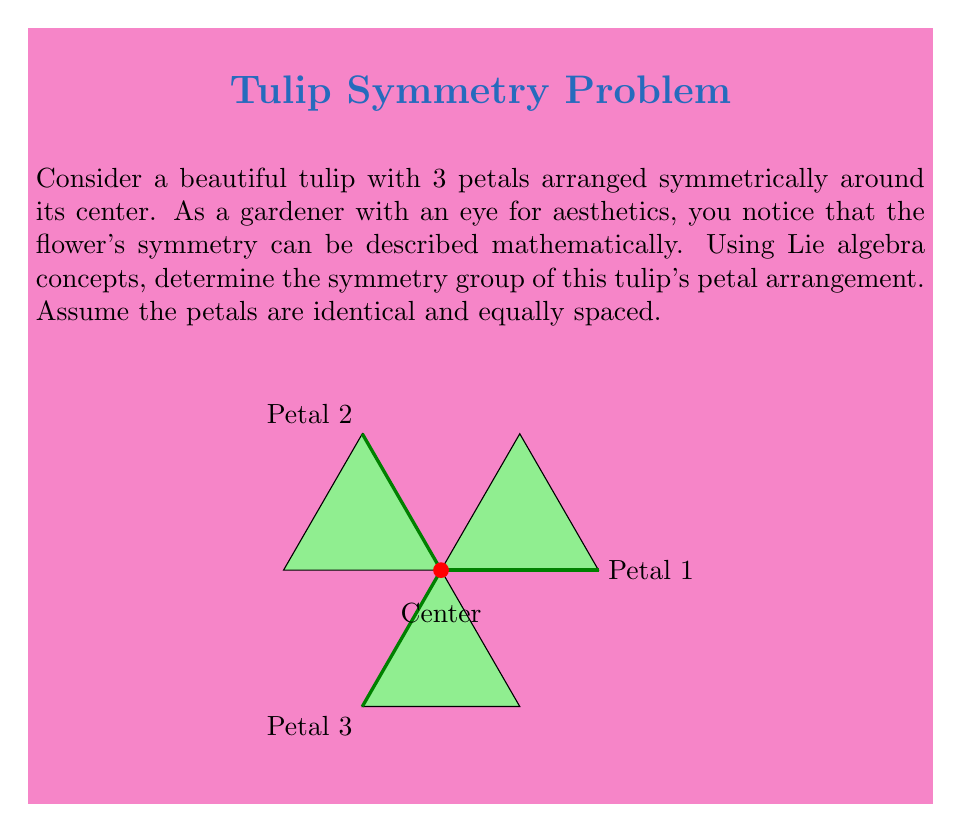Teach me how to tackle this problem. To determine the symmetry group of the tulip's petal arrangement using Lie algebra concepts, we follow these steps:

1) First, we identify the symmetries of the flower:
   - Rotational symmetry: The flower can be rotated by 120° and 240° (or equivalently, -120°) and remain unchanged.
   - Reflection symmetry: The flower has three axes of reflection, one through each petal.

2) These symmetries form a group, which is isomorphic to the dihedral group $D_3$.

3) The Lie algebra associated with this group is $\mathfrak{so}(2)$, the special orthogonal Lie algebra in 2 dimensions.

4) The generators of $\mathfrak{so}(2)$ can be represented by the matrix:

   $$J = \begin{pmatrix} 0 & -1 \\ 1 & 0 \end{pmatrix}$$

5) The rotations in the group can be obtained by exponentiating this generator:

   $$R(\theta) = e^{\theta J} = \begin{pmatrix} \cos\theta & -\sin\theta \\ \sin\theta & \cos\theta \end{pmatrix}$$

6) For our tulip, the rotations are:
   
   $$R(120°) = e^{2\pi/3 J} \quad \text{and} \quad R(240°) = e^{4\pi/3 J}$$

7) The reflections are not part of the connected component of the identity in $SO(2)$, but they can be represented as elements of $O(2)$, the orthogonal group.

8) The full symmetry group is thus the discrete subgroup of $O(2)$ generated by these rotations and reflections, which is $D_3$.

Therefore, the Lie algebra $\mathfrak{so}(2)$ captures the continuous symmetries of the tulip, while the discrete group $D_3$ describes its full symmetry.
Answer: $D_3$, isomorphic to a discrete subgroup of $O(2)$ with Lie algebra $\mathfrak{so}(2)$ 